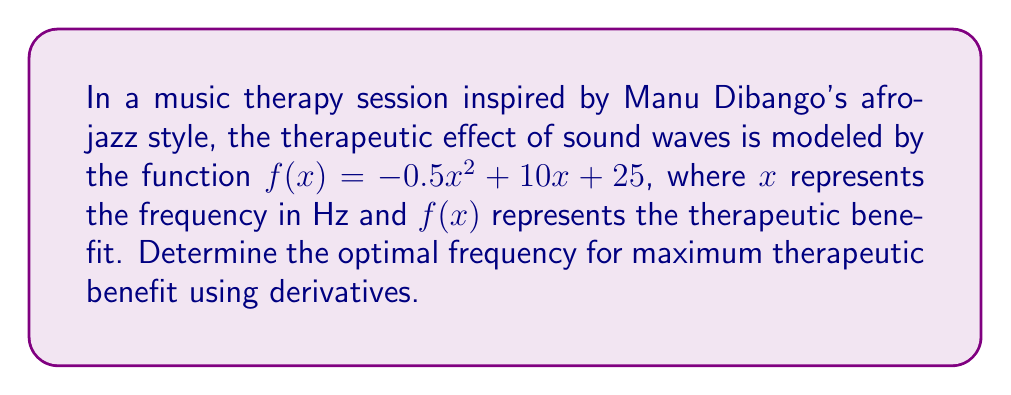Can you solve this math problem? To find the optimal frequency for maximum therapeutic benefit, we need to find the maximum point of the given function using derivatives. Here's the step-by-step process:

1) The given function is $f(x) = -0.5x^2 + 10x + 25$

2) To find the maximum, we need to find where the derivative equals zero. Let's first find the derivative:

   $f'(x) = -x + 10$

3) Set the derivative equal to zero and solve for x:

   $f'(x) = 0$
   $-x + 10 = 0$
   $-x = -10$
   $x = 10$

4) To confirm this is a maximum (not a minimum), we can check the second derivative:

   $f''(x) = -1$

   Since $f''(x)$ is negative, we confirm that $x = 10$ gives a maximum.

5) Therefore, the optimal frequency is 10 Hz.

6) We can calculate the maximum therapeutic benefit by plugging this value back into the original function:

   $f(10) = -0.5(10)^2 + 10(10) + 25$
          $= -50 + 100 + 25$
          $= 75$

Thus, the maximum therapeutic benefit occurs at a frequency of 10 Hz, with a benefit value of 75 units.
Answer: 10 Hz 